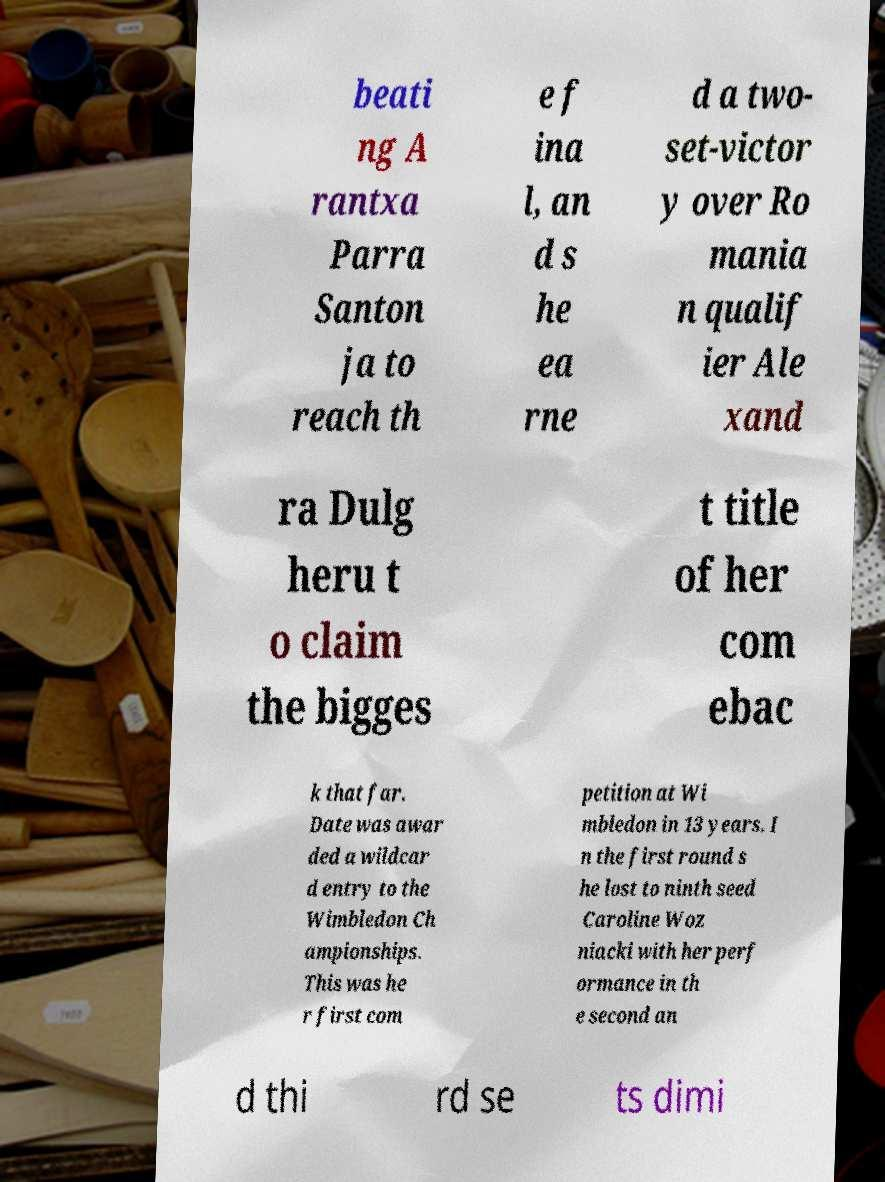What messages or text are displayed in this image? I need them in a readable, typed format. beati ng A rantxa Parra Santon ja to reach th e f ina l, an d s he ea rne d a two- set-victor y over Ro mania n qualif ier Ale xand ra Dulg heru t o claim the bigges t title of her com ebac k that far. Date was awar ded a wildcar d entry to the Wimbledon Ch ampionships. This was he r first com petition at Wi mbledon in 13 years. I n the first round s he lost to ninth seed Caroline Woz niacki with her perf ormance in th e second an d thi rd se ts dimi 